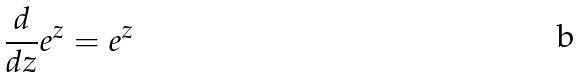Convert formula to latex. <formula><loc_0><loc_0><loc_500><loc_500>\frac { d } { d z } e ^ { z } = e ^ { z }</formula> 